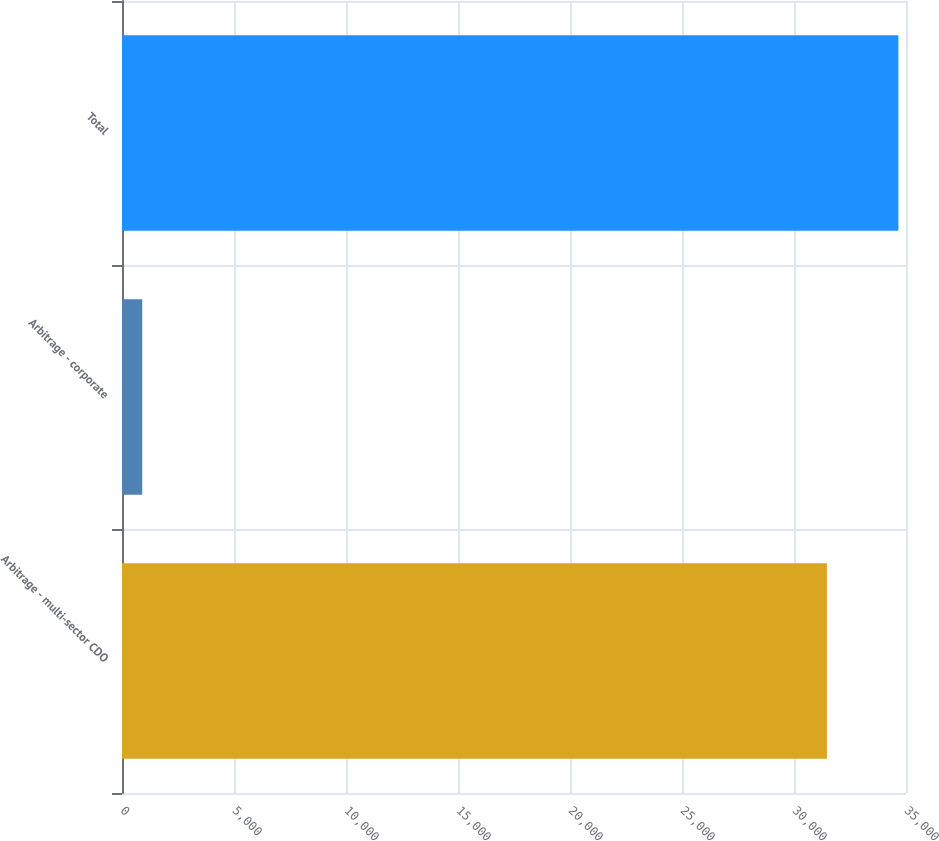<chart> <loc_0><loc_0><loc_500><loc_500><bar_chart><fcel>Arbitrage - multi-sector CDO<fcel>Arbitrage - corporate<fcel>Total<nl><fcel>31469<fcel>902<fcel>34660.2<nl></chart> 